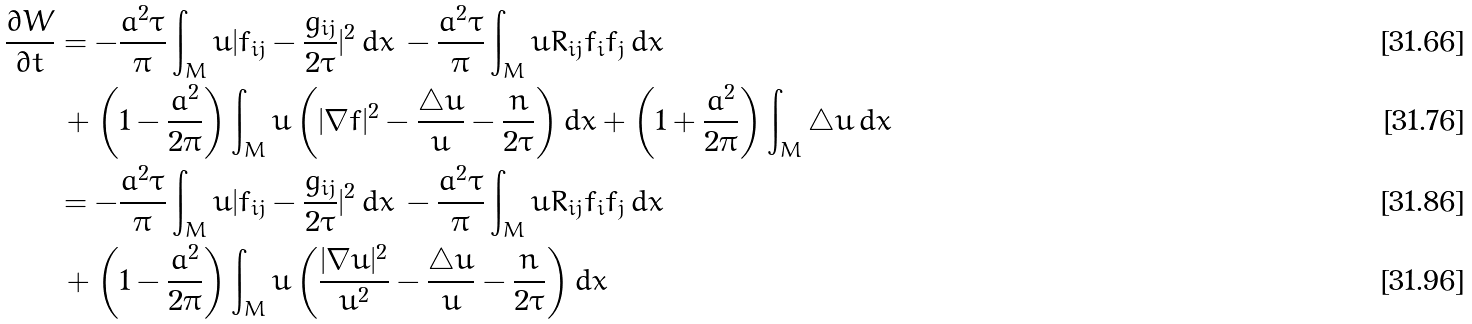Convert formula to latex. <formula><loc_0><loc_0><loc_500><loc_500>\frac { \partial W } { \partial t } & = - \frac { a ^ { 2 } \tau } { \pi } \int _ { M } u | f _ { i j } - \frac { g _ { i j } } { 2 \tau } | ^ { 2 } \, d x \, - \frac { a ^ { 2 } \tau } { \pi } \int _ { M } u R _ { i j } f _ { i } f _ { j } \, d x \\ & \, + \left ( 1 - \frac { a ^ { 2 } } { 2 \pi } \right ) \int _ { M } u \left ( | \nabla f | ^ { 2 } - \frac { \triangle u } { u } - \frac { n } { 2 \tau } \right ) d x + \left ( 1 + \frac { a ^ { 2 } } { 2 \pi } \right ) \int _ { M } \triangle u \, d x \\ & = - \frac { a ^ { 2 } \tau } { \pi } \int _ { M } u | f _ { i j } - \frac { g _ { i j } } { 2 \tau } | ^ { 2 } \, d x \, - \frac { a ^ { 2 } \tau } { \pi } \int _ { M } u R _ { i j } f _ { i } f _ { j } \, d x \\ & \, + \left ( 1 - \frac { a ^ { 2 } } { 2 \pi } \right ) \int _ { M } u \left ( \frac { | \nabla u | ^ { 2 } } { u ^ { 2 } } - \frac { \triangle u } { u } - \frac { n } { 2 \tau } \right ) d x</formula> 